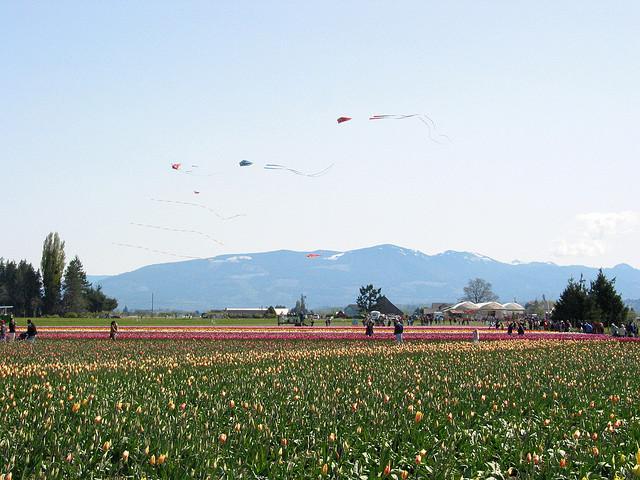Are these people in a park?
Short answer required. Yes. What is all the green?
Answer briefly. Grass. What are people flying?
Write a very short answer. Kites. Is the terrain mountainous?
Concise answer only. Yes. What types of trees are there?
Answer briefly. Pine. Is there a windmill?
Write a very short answer. No. 